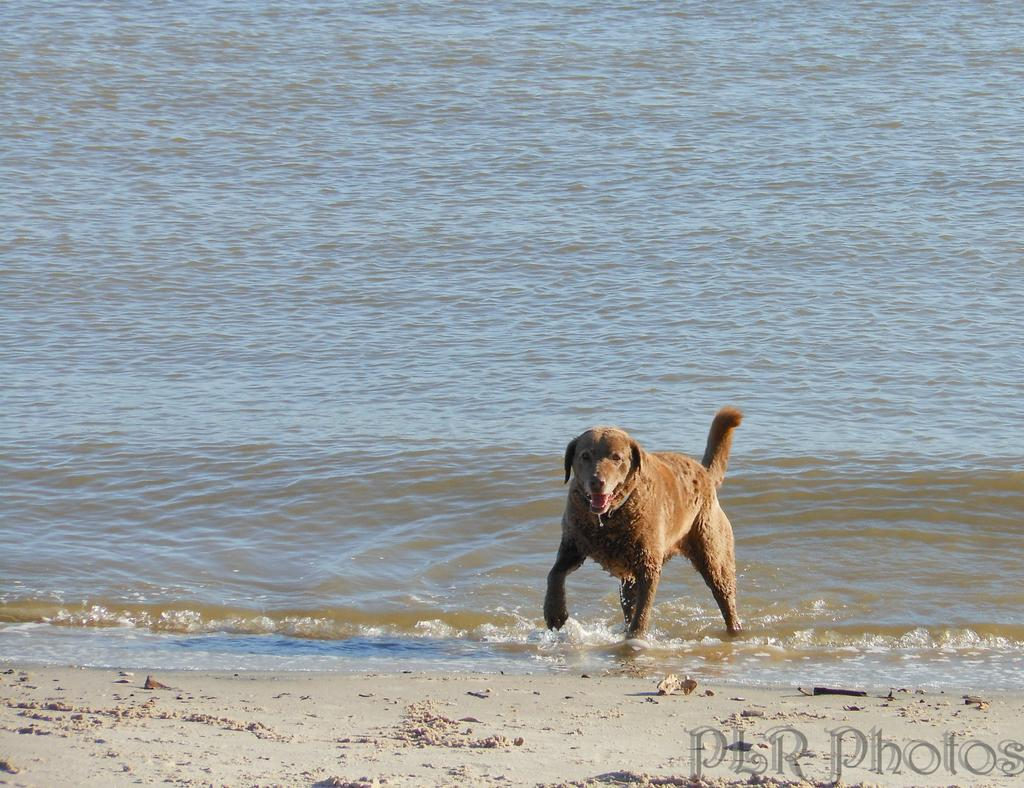What is the main subject of the image? There is a dog in the water. What is visible at the bottom of the image? There is sand at the bottom of the image. Can you describe any additional features of the image? There is a watermark in the bottom right corner of the image. What is the tendency of the donkey in the image? There is no donkey present in the image, so it is not possible to determine its tendency. Is the dog in the image being held in jail? There is no indication of a jail or any confinement in the image; the dog is in the water. 